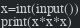<code> <loc_0><loc_0><loc_500><loc_500><_Python_>x=int(input())
print(x*x*x)
</code> 